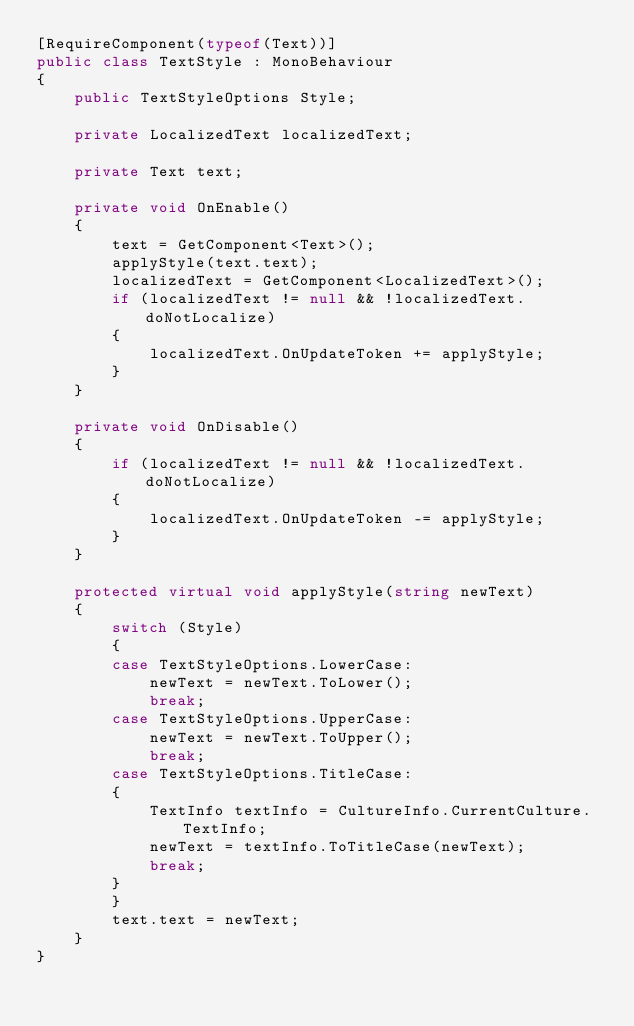Convert code to text. <code><loc_0><loc_0><loc_500><loc_500><_C#_>[RequireComponent(typeof(Text))]
public class TextStyle : MonoBehaviour
{
	public TextStyleOptions Style;

	private LocalizedText localizedText;

	private Text text;

	private void OnEnable()
	{
		text = GetComponent<Text>();
		applyStyle(text.text);
		localizedText = GetComponent<LocalizedText>();
		if (localizedText != null && !localizedText.doNotLocalize)
		{
			localizedText.OnUpdateToken += applyStyle;
		}
	}

	private void OnDisable()
	{
		if (localizedText != null && !localizedText.doNotLocalize)
		{
			localizedText.OnUpdateToken -= applyStyle;
		}
	}

	protected virtual void applyStyle(string newText)
	{
		switch (Style)
		{
		case TextStyleOptions.LowerCase:
			newText = newText.ToLower();
			break;
		case TextStyleOptions.UpperCase:
			newText = newText.ToUpper();
			break;
		case TextStyleOptions.TitleCase:
		{
			TextInfo textInfo = CultureInfo.CurrentCulture.TextInfo;
			newText = textInfo.ToTitleCase(newText);
			break;
		}
		}
		text.text = newText;
	}
}
</code> 